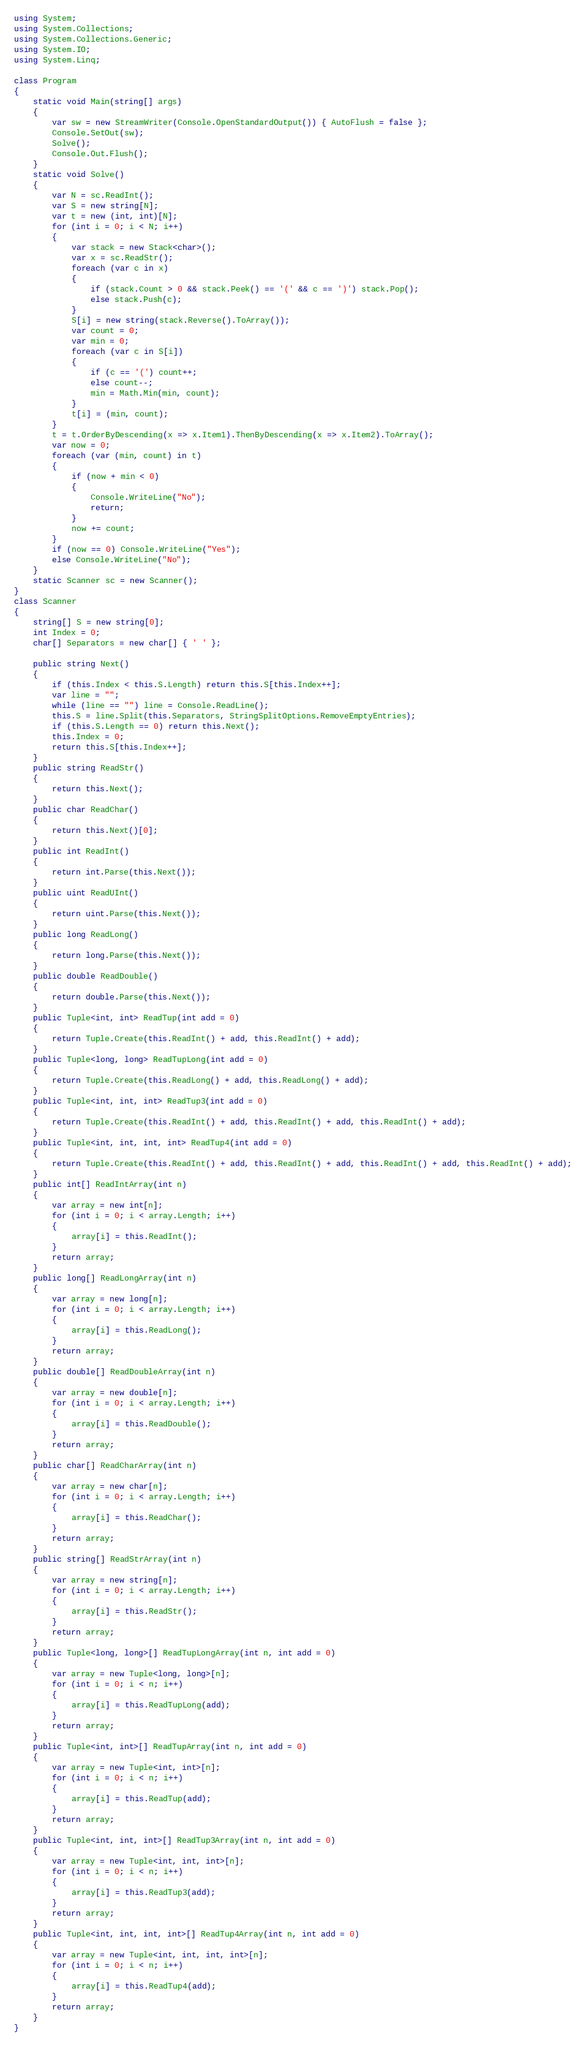Convert code to text. <code><loc_0><loc_0><loc_500><loc_500><_C#_>using System;
using System.Collections;
using System.Collections.Generic;
using System.IO;
using System.Linq;

class Program
{
    static void Main(string[] args)
    {
        var sw = new StreamWriter(Console.OpenStandardOutput()) { AutoFlush = false };
        Console.SetOut(sw);
        Solve();
        Console.Out.Flush();
    }
    static void Solve()
    {
        var N = sc.ReadInt();
        var S = new string[N];
        var t = new (int, int)[N];
        for (int i = 0; i < N; i++)
        {
            var stack = new Stack<char>();
            var x = sc.ReadStr();
            foreach (var c in x)
            {
                if (stack.Count > 0 && stack.Peek() == '(' && c == ')') stack.Pop();
                else stack.Push(c);
            }
            S[i] = new string(stack.Reverse().ToArray());
            var count = 0;
            var min = 0;
            foreach (var c in S[i])
            {
                if (c == '(') count++;
                else count--;
                min = Math.Min(min, count);
            }
            t[i] = (min, count);
        }
        t = t.OrderByDescending(x => x.Item1).ThenByDescending(x => x.Item2).ToArray();
        var now = 0;
        foreach (var (min, count) in t)
        {
            if (now + min < 0)
            {
                Console.WriteLine("No");
                return;
            }
            now += count;
        }
        if (now == 0) Console.WriteLine("Yes");
        else Console.WriteLine("No");
    }
    static Scanner sc = new Scanner();
}
class Scanner
{
    string[] S = new string[0];
    int Index = 0;
    char[] Separators = new char[] { ' ' };

    public string Next()
    {
        if (this.Index < this.S.Length) return this.S[this.Index++];
        var line = "";
        while (line == "") line = Console.ReadLine();
        this.S = line.Split(this.Separators, StringSplitOptions.RemoveEmptyEntries);
        if (this.S.Length == 0) return this.Next();
        this.Index = 0;
        return this.S[this.Index++];
    }
    public string ReadStr()
    {
        return this.Next();
    }
    public char ReadChar()
    {
        return this.Next()[0];
    }
    public int ReadInt()
    {
        return int.Parse(this.Next());
    }
    public uint ReadUInt()
    {
        return uint.Parse(this.Next());
    }
    public long ReadLong()
    {
        return long.Parse(this.Next());
    }
    public double ReadDouble()
    {
        return double.Parse(this.Next());
    }
    public Tuple<int, int> ReadTup(int add = 0)
    {
        return Tuple.Create(this.ReadInt() + add, this.ReadInt() + add);
    }
    public Tuple<long, long> ReadTupLong(int add = 0)
    {
        return Tuple.Create(this.ReadLong() + add, this.ReadLong() + add);
    }
    public Tuple<int, int, int> ReadTup3(int add = 0)
    {
        return Tuple.Create(this.ReadInt() + add, this.ReadInt() + add, this.ReadInt() + add);
    }
    public Tuple<int, int, int, int> ReadTup4(int add = 0)
    {
        return Tuple.Create(this.ReadInt() + add, this.ReadInt() + add, this.ReadInt() + add, this.ReadInt() + add);
    }
    public int[] ReadIntArray(int n)
    {
        var array = new int[n];
        for (int i = 0; i < array.Length; i++)
        {
            array[i] = this.ReadInt();
        }
        return array;
    }
    public long[] ReadLongArray(int n)
    {
        var array = new long[n];
        for (int i = 0; i < array.Length; i++)
        {
            array[i] = this.ReadLong();
        }
        return array;
    }
    public double[] ReadDoubleArray(int n)
    {
        var array = new double[n];
        for (int i = 0; i < array.Length; i++)
        {
            array[i] = this.ReadDouble();
        }
        return array;
    }
    public char[] ReadCharArray(int n)
    {
        var array = new char[n];
        for (int i = 0; i < array.Length; i++)
        {
            array[i] = this.ReadChar();
        }
        return array;
    }
    public string[] ReadStrArray(int n)
    {
        var array = new string[n];
        for (int i = 0; i < array.Length; i++)
        {
            array[i] = this.ReadStr();
        }
        return array;
    }
    public Tuple<long, long>[] ReadTupLongArray(int n, int add = 0)
    {
        var array = new Tuple<long, long>[n];
        for (int i = 0; i < n; i++)
        {
            array[i] = this.ReadTupLong(add);
        }
        return array;
    }
    public Tuple<int, int>[] ReadTupArray(int n, int add = 0)
    {
        var array = new Tuple<int, int>[n];
        for (int i = 0; i < n; i++)
        {
            array[i] = this.ReadTup(add);
        }
        return array;
    }
    public Tuple<int, int, int>[] ReadTup3Array(int n, int add = 0)
    {
        var array = new Tuple<int, int, int>[n];
        for (int i = 0; i < n; i++)
        {
            array[i] = this.ReadTup3(add);
        }
        return array;
    }
    public Tuple<int, int, int, int>[] ReadTup4Array(int n, int add = 0)
    {
        var array = new Tuple<int, int, int, int>[n];
        for (int i = 0; i < n; i++)
        {
            array[i] = this.ReadTup4(add);
        }
        return array;
    }
}
</code> 